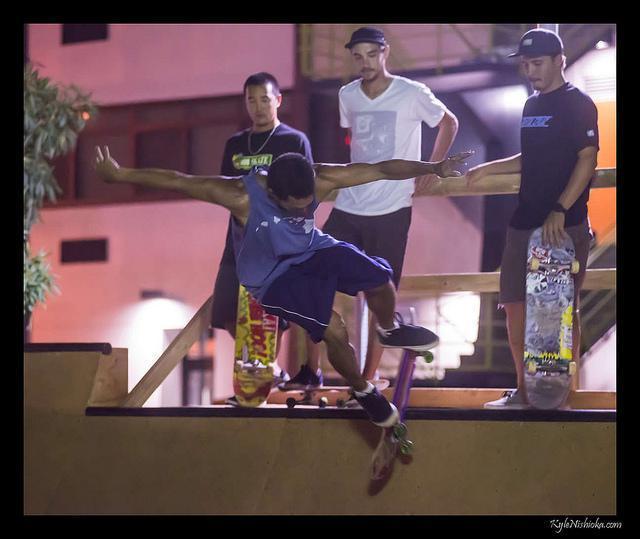How many people are shown?
Give a very brief answer. 4. How many people don't have a skateboard?
Give a very brief answer. 0. How many skateboards are in the photo?
Give a very brief answer. 3. How many people can be seen?
Give a very brief answer. 4. 